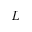Convert formula to latex. <formula><loc_0><loc_0><loc_500><loc_500>L</formula> 